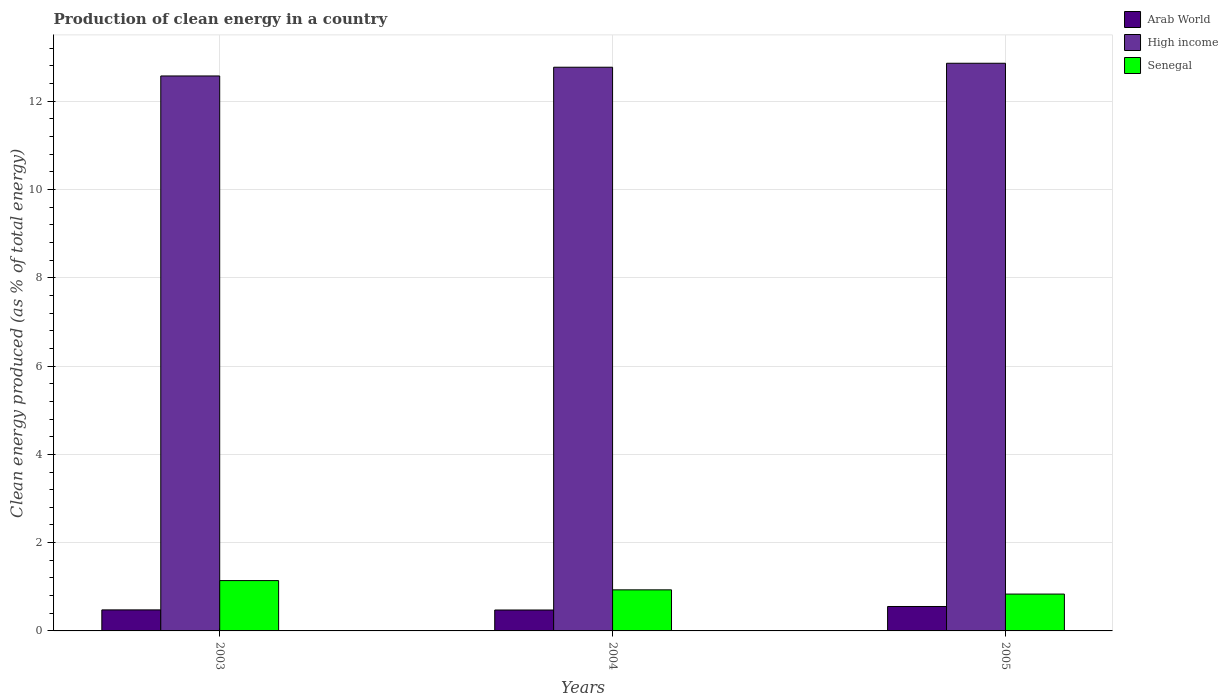How many groups of bars are there?
Your answer should be compact. 3. Are the number of bars per tick equal to the number of legend labels?
Give a very brief answer. Yes. Are the number of bars on each tick of the X-axis equal?
Provide a short and direct response. Yes. What is the label of the 2nd group of bars from the left?
Give a very brief answer. 2004. What is the percentage of clean energy produced in High income in 2003?
Give a very brief answer. 12.57. Across all years, what is the maximum percentage of clean energy produced in Senegal?
Provide a short and direct response. 1.14. Across all years, what is the minimum percentage of clean energy produced in Senegal?
Keep it short and to the point. 0.84. In which year was the percentage of clean energy produced in High income maximum?
Your answer should be compact. 2005. What is the total percentage of clean energy produced in Arab World in the graph?
Make the answer very short. 1.5. What is the difference between the percentage of clean energy produced in Arab World in 2003 and that in 2004?
Make the answer very short. 0. What is the difference between the percentage of clean energy produced in Senegal in 2003 and the percentage of clean energy produced in Arab World in 2005?
Keep it short and to the point. 0.59. What is the average percentage of clean energy produced in High income per year?
Offer a terse response. 12.74. In the year 2005, what is the difference between the percentage of clean energy produced in Arab World and percentage of clean energy produced in Senegal?
Your answer should be compact. -0.28. What is the ratio of the percentage of clean energy produced in Arab World in 2003 to that in 2004?
Give a very brief answer. 1.01. Is the difference between the percentage of clean energy produced in Arab World in 2003 and 2005 greater than the difference between the percentage of clean energy produced in Senegal in 2003 and 2005?
Give a very brief answer. No. What is the difference between the highest and the second highest percentage of clean energy produced in Arab World?
Your answer should be very brief. 0.08. What is the difference between the highest and the lowest percentage of clean energy produced in High income?
Ensure brevity in your answer.  0.29. Is the sum of the percentage of clean energy produced in High income in 2004 and 2005 greater than the maximum percentage of clean energy produced in Senegal across all years?
Your answer should be very brief. Yes. What does the 1st bar from the left in 2005 represents?
Your response must be concise. Arab World. What does the 3rd bar from the right in 2005 represents?
Offer a very short reply. Arab World. How many bars are there?
Provide a short and direct response. 9. What is the difference between two consecutive major ticks on the Y-axis?
Your answer should be very brief. 2. Does the graph contain any zero values?
Keep it short and to the point. No. Does the graph contain grids?
Keep it short and to the point. Yes. Where does the legend appear in the graph?
Provide a short and direct response. Top right. How many legend labels are there?
Offer a terse response. 3. How are the legend labels stacked?
Your response must be concise. Vertical. What is the title of the graph?
Your answer should be very brief. Production of clean energy in a country. Does "Fiji" appear as one of the legend labels in the graph?
Ensure brevity in your answer.  No. What is the label or title of the Y-axis?
Make the answer very short. Clean energy produced (as % of total energy). What is the Clean energy produced (as % of total energy) in Arab World in 2003?
Your answer should be compact. 0.48. What is the Clean energy produced (as % of total energy) in High income in 2003?
Ensure brevity in your answer.  12.57. What is the Clean energy produced (as % of total energy) of Senegal in 2003?
Make the answer very short. 1.14. What is the Clean energy produced (as % of total energy) in Arab World in 2004?
Give a very brief answer. 0.47. What is the Clean energy produced (as % of total energy) of High income in 2004?
Offer a very short reply. 12.77. What is the Clean energy produced (as % of total energy) of Senegal in 2004?
Offer a very short reply. 0.93. What is the Clean energy produced (as % of total energy) of Arab World in 2005?
Provide a succinct answer. 0.55. What is the Clean energy produced (as % of total energy) in High income in 2005?
Provide a succinct answer. 12.86. What is the Clean energy produced (as % of total energy) of Senegal in 2005?
Provide a short and direct response. 0.84. Across all years, what is the maximum Clean energy produced (as % of total energy) of Arab World?
Your answer should be very brief. 0.55. Across all years, what is the maximum Clean energy produced (as % of total energy) in High income?
Ensure brevity in your answer.  12.86. Across all years, what is the maximum Clean energy produced (as % of total energy) of Senegal?
Your answer should be compact. 1.14. Across all years, what is the minimum Clean energy produced (as % of total energy) of Arab World?
Your answer should be compact. 0.47. Across all years, what is the minimum Clean energy produced (as % of total energy) of High income?
Offer a terse response. 12.57. Across all years, what is the minimum Clean energy produced (as % of total energy) in Senegal?
Ensure brevity in your answer.  0.84. What is the total Clean energy produced (as % of total energy) in Arab World in the graph?
Provide a succinct answer. 1.5. What is the total Clean energy produced (as % of total energy) in High income in the graph?
Ensure brevity in your answer.  38.21. What is the total Clean energy produced (as % of total energy) in Senegal in the graph?
Your answer should be compact. 2.91. What is the difference between the Clean energy produced (as % of total energy) in Arab World in 2003 and that in 2004?
Make the answer very short. 0. What is the difference between the Clean energy produced (as % of total energy) of High income in 2003 and that in 2004?
Make the answer very short. -0.2. What is the difference between the Clean energy produced (as % of total energy) in Senegal in 2003 and that in 2004?
Your answer should be compact. 0.21. What is the difference between the Clean energy produced (as % of total energy) of Arab World in 2003 and that in 2005?
Make the answer very short. -0.08. What is the difference between the Clean energy produced (as % of total energy) in High income in 2003 and that in 2005?
Give a very brief answer. -0.29. What is the difference between the Clean energy produced (as % of total energy) in Senegal in 2003 and that in 2005?
Give a very brief answer. 0.31. What is the difference between the Clean energy produced (as % of total energy) in Arab World in 2004 and that in 2005?
Keep it short and to the point. -0.08. What is the difference between the Clean energy produced (as % of total energy) of High income in 2004 and that in 2005?
Your response must be concise. -0.09. What is the difference between the Clean energy produced (as % of total energy) in Senegal in 2004 and that in 2005?
Offer a terse response. 0.1. What is the difference between the Clean energy produced (as % of total energy) in Arab World in 2003 and the Clean energy produced (as % of total energy) in High income in 2004?
Give a very brief answer. -12.3. What is the difference between the Clean energy produced (as % of total energy) of Arab World in 2003 and the Clean energy produced (as % of total energy) of Senegal in 2004?
Make the answer very short. -0.45. What is the difference between the Clean energy produced (as % of total energy) of High income in 2003 and the Clean energy produced (as % of total energy) of Senegal in 2004?
Your response must be concise. 11.64. What is the difference between the Clean energy produced (as % of total energy) of Arab World in 2003 and the Clean energy produced (as % of total energy) of High income in 2005?
Your response must be concise. -12.38. What is the difference between the Clean energy produced (as % of total energy) of Arab World in 2003 and the Clean energy produced (as % of total energy) of Senegal in 2005?
Your response must be concise. -0.36. What is the difference between the Clean energy produced (as % of total energy) of High income in 2003 and the Clean energy produced (as % of total energy) of Senegal in 2005?
Your response must be concise. 11.74. What is the difference between the Clean energy produced (as % of total energy) of Arab World in 2004 and the Clean energy produced (as % of total energy) of High income in 2005?
Provide a succinct answer. -12.39. What is the difference between the Clean energy produced (as % of total energy) in Arab World in 2004 and the Clean energy produced (as % of total energy) in Senegal in 2005?
Make the answer very short. -0.36. What is the difference between the Clean energy produced (as % of total energy) in High income in 2004 and the Clean energy produced (as % of total energy) in Senegal in 2005?
Provide a short and direct response. 11.94. What is the average Clean energy produced (as % of total energy) of Arab World per year?
Your answer should be compact. 0.5. What is the average Clean energy produced (as % of total energy) in High income per year?
Give a very brief answer. 12.74. What is the average Clean energy produced (as % of total energy) of Senegal per year?
Keep it short and to the point. 0.97. In the year 2003, what is the difference between the Clean energy produced (as % of total energy) in Arab World and Clean energy produced (as % of total energy) in High income?
Offer a very short reply. -12.1. In the year 2003, what is the difference between the Clean energy produced (as % of total energy) in Arab World and Clean energy produced (as % of total energy) in Senegal?
Offer a very short reply. -0.66. In the year 2003, what is the difference between the Clean energy produced (as % of total energy) of High income and Clean energy produced (as % of total energy) of Senegal?
Your answer should be very brief. 11.43. In the year 2004, what is the difference between the Clean energy produced (as % of total energy) of Arab World and Clean energy produced (as % of total energy) of High income?
Make the answer very short. -12.3. In the year 2004, what is the difference between the Clean energy produced (as % of total energy) in Arab World and Clean energy produced (as % of total energy) in Senegal?
Provide a short and direct response. -0.46. In the year 2004, what is the difference between the Clean energy produced (as % of total energy) in High income and Clean energy produced (as % of total energy) in Senegal?
Keep it short and to the point. 11.84. In the year 2005, what is the difference between the Clean energy produced (as % of total energy) of Arab World and Clean energy produced (as % of total energy) of High income?
Give a very brief answer. -12.31. In the year 2005, what is the difference between the Clean energy produced (as % of total energy) in Arab World and Clean energy produced (as % of total energy) in Senegal?
Your response must be concise. -0.28. In the year 2005, what is the difference between the Clean energy produced (as % of total energy) in High income and Clean energy produced (as % of total energy) in Senegal?
Provide a short and direct response. 12.03. What is the ratio of the Clean energy produced (as % of total energy) in Arab World in 2003 to that in 2004?
Make the answer very short. 1.01. What is the ratio of the Clean energy produced (as % of total energy) of High income in 2003 to that in 2004?
Offer a terse response. 0.98. What is the ratio of the Clean energy produced (as % of total energy) in Senegal in 2003 to that in 2004?
Offer a very short reply. 1.23. What is the ratio of the Clean energy produced (as % of total energy) of Arab World in 2003 to that in 2005?
Ensure brevity in your answer.  0.86. What is the ratio of the Clean energy produced (as % of total energy) of High income in 2003 to that in 2005?
Your answer should be compact. 0.98. What is the ratio of the Clean energy produced (as % of total energy) in Senegal in 2003 to that in 2005?
Ensure brevity in your answer.  1.37. What is the ratio of the Clean energy produced (as % of total energy) in Arab World in 2004 to that in 2005?
Offer a very short reply. 0.86. What is the ratio of the Clean energy produced (as % of total energy) of High income in 2004 to that in 2005?
Offer a very short reply. 0.99. What is the ratio of the Clean energy produced (as % of total energy) in Senegal in 2004 to that in 2005?
Make the answer very short. 1.11. What is the difference between the highest and the second highest Clean energy produced (as % of total energy) of Arab World?
Give a very brief answer. 0.08. What is the difference between the highest and the second highest Clean energy produced (as % of total energy) of High income?
Offer a very short reply. 0.09. What is the difference between the highest and the second highest Clean energy produced (as % of total energy) of Senegal?
Provide a succinct answer. 0.21. What is the difference between the highest and the lowest Clean energy produced (as % of total energy) in Arab World?
Give a very brief answer. 0.08. What is the difference between the highest and the lowest Clean energy produced (as % of total energy) in High income?
Give a very brief answer. 0.29. What is the difference between the highest and the lowest Clean energy produced (as % of total energy) in Senegal?
Give a very brief answer. 0.31. 